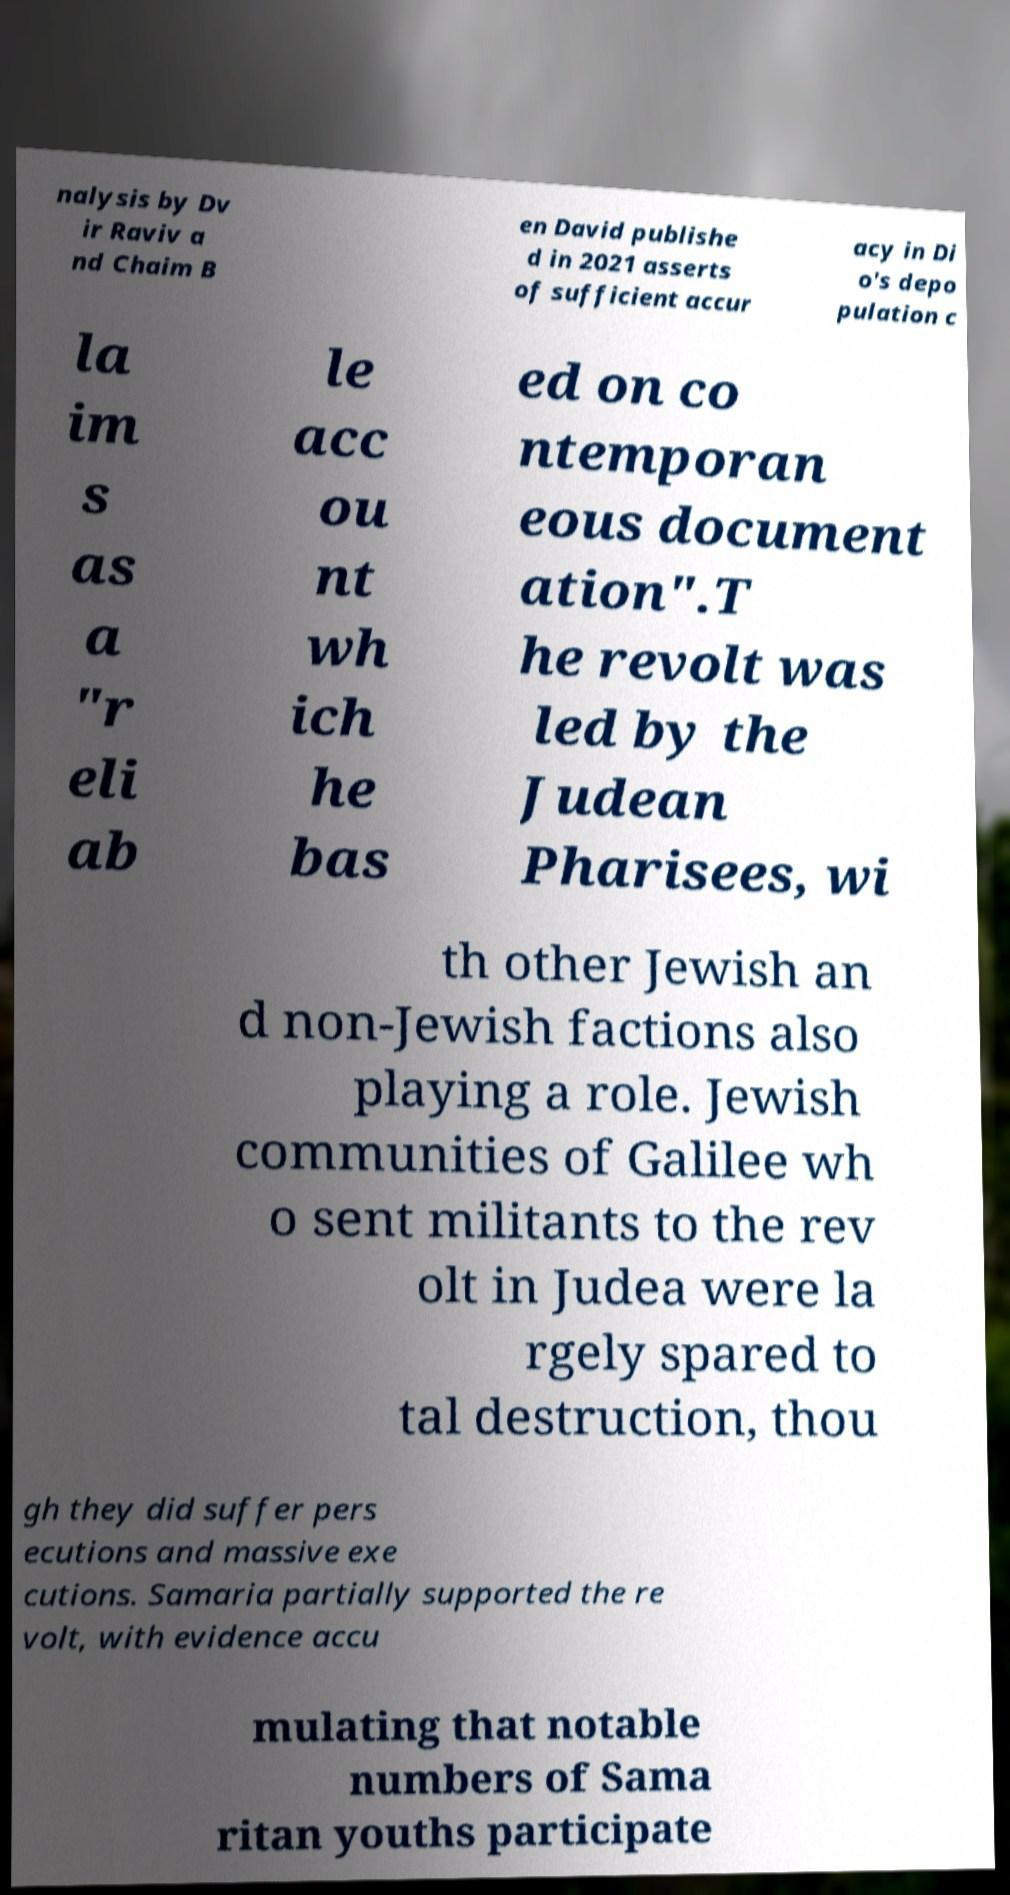What messages or text are displayed in this image? I need them in a readable, typed format. nalysis by Dv ir Raviv a nd Chaim B en David publishe d in 2021 asserts of sufficient accur acy in Di o's depo pulation c la im s as a "r eli ab le acc ou nt wh ich he bas ed on co ntemporan eous document ation".T he revolt was led by the Judean Pharisees, wi th other Jewish an d non-Jewish factions also playing a role. Jewish communities of Galilee wh o sent militants to the rev olt in Judea were la rgely spared to tal destruction, thou gh they did suffer pers ecutions and massive exe cutions. Samaria partially supported the re volt, with evidence accu mulating that notable numbers of Sama ritan youths participate 